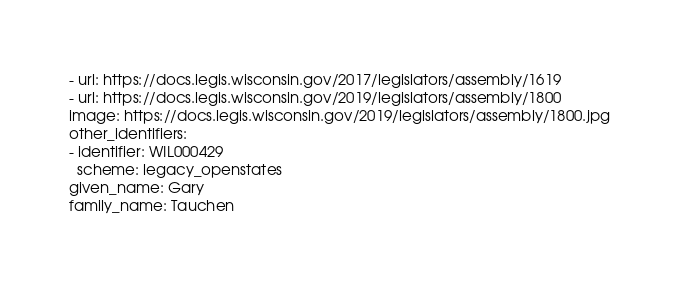<code> <loc_0><loc_0><loc_500><loc_500><_YAML_>- url: https://docs.legis.wisconsin.gov/2017/legislators/assembly/1619
- url: https://docs.legis.wisconsin.gov/2019/legislators/assembly/1800
image: https://docs.legis.wisconsin.gov/2019/legislators/assembly/1800.jpg
other_identifiers:
- identifier: WIL000429
  scheme: legacy_openstates
given_name: Gary
family_name: Tauchen
</code> 